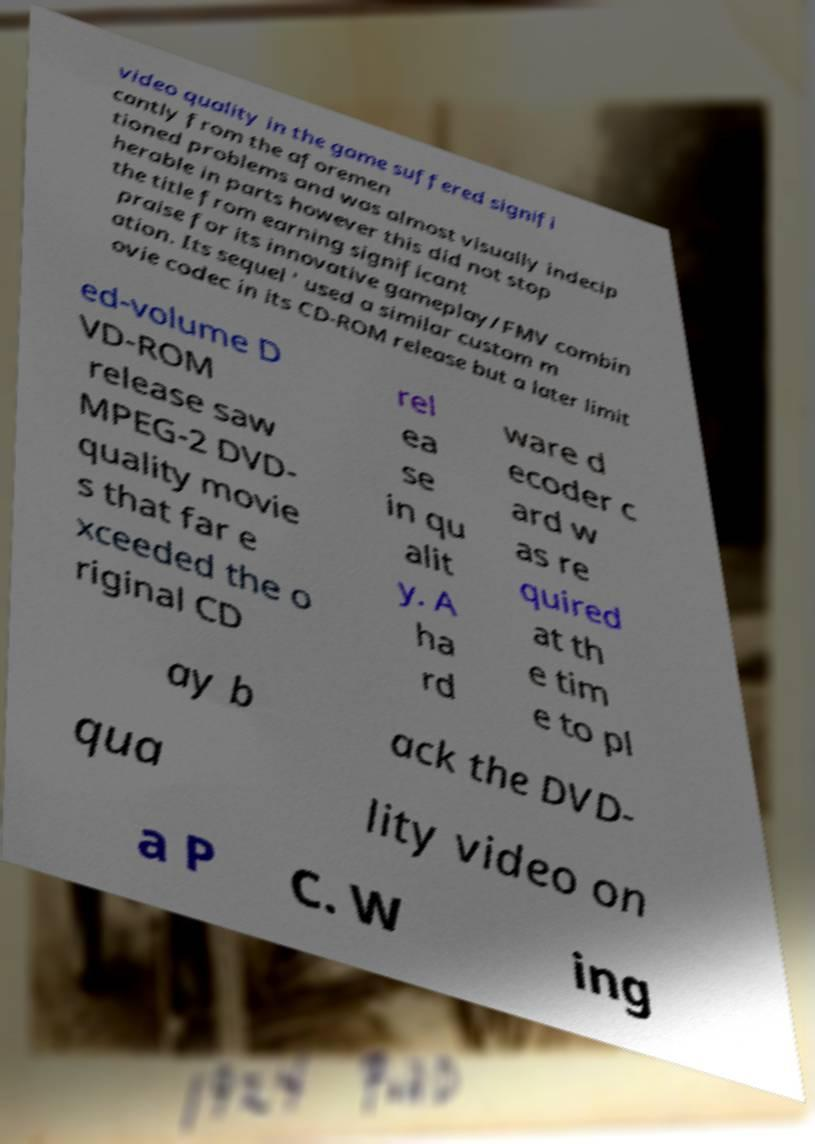What messages or text are displayed in this image? I need them in a readable, typed format. video quality in the game suffered signifi cantly from the aforemen tioned problems and was almost visually indecip herable in parts however this did not stop the title from earning significant praise for its innovative gameplay/FMV combin ation. Its sequel ' used a similar custom m ovie codec in its CD-ROM release but a later limit ed-volume D VD-ROM release saw MPEG-2 DVD- quality movie s that far e xceeded the o riginal CD rel ea se in qu alit y. A ha rd ware d ecoder c ard w as re quired at th e tim e to pl ay b ack the DVD- qua lity video on a P C. W ing 